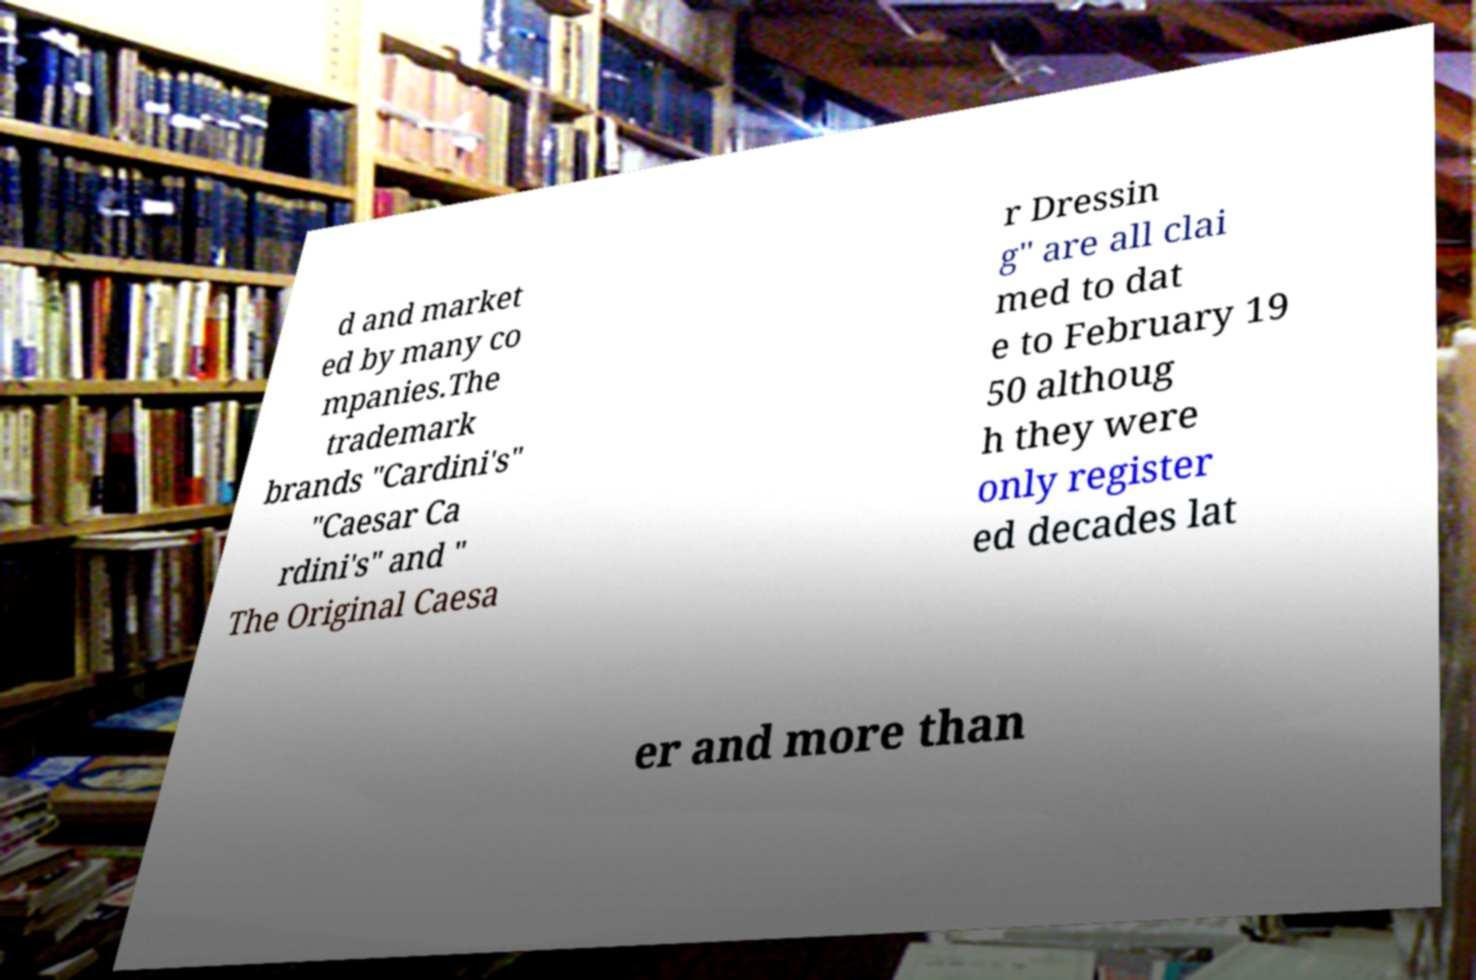For documentation purposes, I need the text within this image transcribed. Could you provide that? d and market ed by many co mpanies.The trademark brands "Cardini's" "Caesar Ca rdini's" and " The Original Caesa r Dressin g" are all clai med to dat e to February 19 50 althoug h they were only register ed decades lat er and more than 